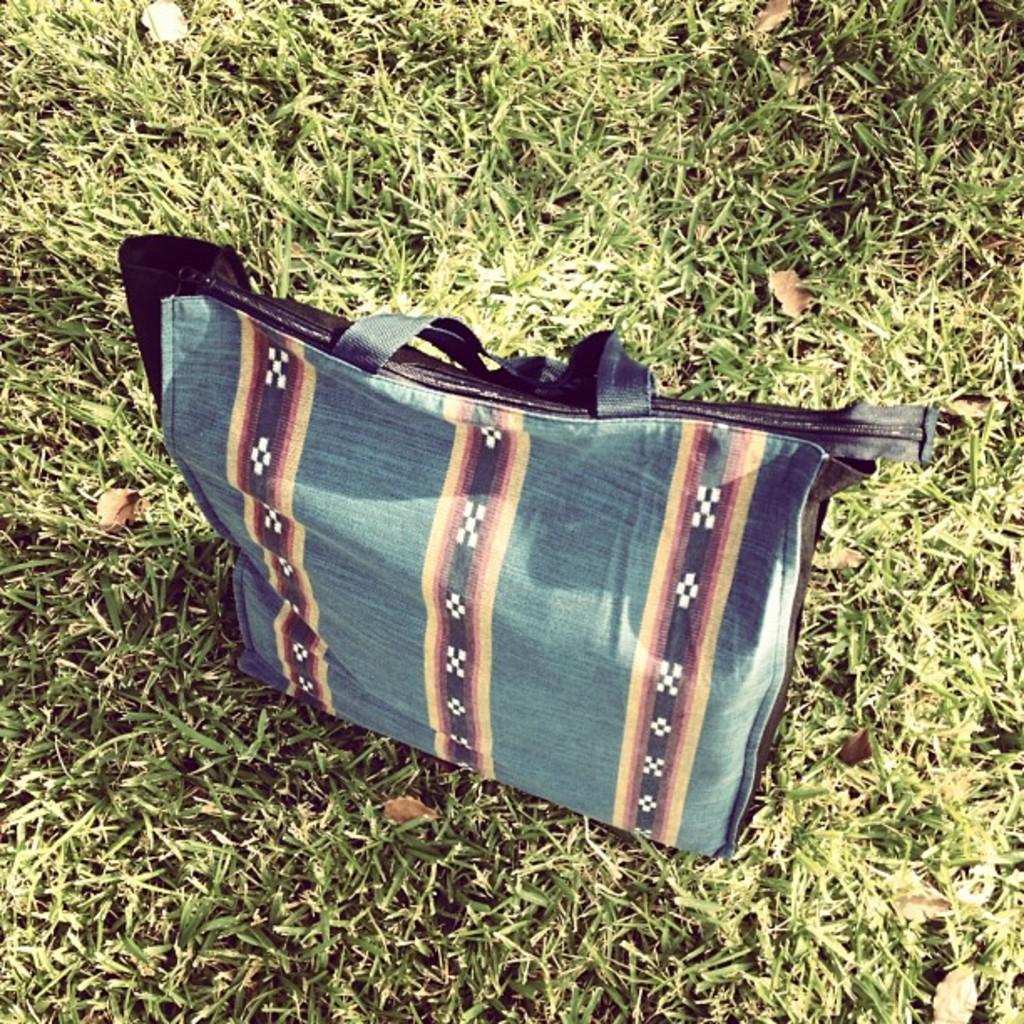What is the main object visible in the image? There is a handbag in the image. What type of friction can be observed between the handbag and the surface it is placed on in the image? There is no information provided about the surface or any friction between the handbag and the surface in the image. What statement is being made by the presence of the handbag in the image? The presence of the handbag in the image does not inherently make a statement; it is simply an object visible in the image. 